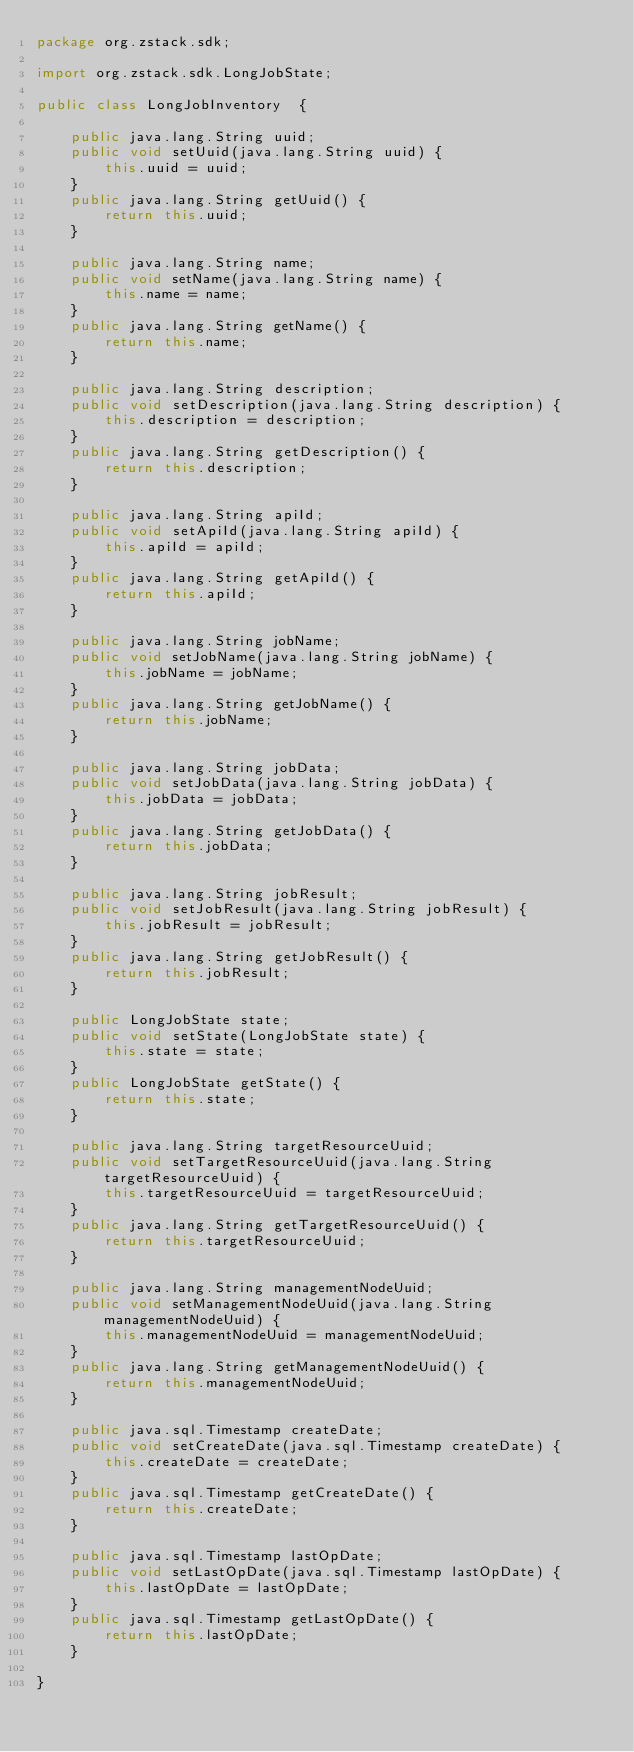<code> <loc_0><loc_0><loc_500><loc_500><_Java_>package org.zstack.sdk;

import org.zstack.sdk.LongJobState;

public class LongJobInventory  {

    public java.lang.String uuid;
    public void setUuid(java.lang.String uuid) {
        this.uuid = uuid;
    }
    public java.lang.String getUuid() {
        return this.uuid;
    }

    public java.lang.String name;
    public void setName(java.lang.String name) {
        this.name = name;
    }
    public java.lang.String getName() {
        return this.name;
    }

    public java.lang.String description;
    public void setDescription(java.lang.String description) {
        this.description = description;
    }
    public java.lang.String getDescription() {
        return this.description;
    }

    public java.lang.String apiId;
    public void setApiId(java.lang.String apiId) {
        this.apiId = apiId;
    }
    public java.lang.String getApiId() {
        return this.apiId;
    }

    public java.lang.String jobName;
    public void setJobName(java.lang.String jobName) {
        this.jobName = jobName;
    }
    public java.lang.String getJobName() {
        return this.jobName;
    }

    public java.lang.String jobData;
    public void setJobData(java.lang.String jobData) {
        this.jobData = jobData;
    }
    public java.lang.String getJobData() {
        return this.jobData;
    }

    public java.lang.String jobResult;
    public void setJobResult(java.lang.String jobResult) {
        this.jobResult = jobResult;
    }
    public java.lang.String getJobResult() {
        return this.jobResult;
    }

    public LongJobState state;
    public void setState(LongJobState state) {
        this.state = state;
    }
    public LongJobState getState() {
        return this.state;
    }

    public java.lang.String targetResourceUuid;
    public void setTargetResourceUuid(java.lang.String targetResourceUuid) {
        this.targetResourceUuid = targetResourceUuid;
    }
    public java.lang.String getTargetResourceUuid() {
        return this.targetResourceUuid;
    }

    public java.lang.String managementNodeUuid;
    public void setManagementNodeUuid(java.lang.String managementNodeUuid) {
        this.managementNodeUuid = managementNodeUuid;
    }
    public java.lang.String getManagementNodeUuid() {
        return this.managementNodeUuid;
    }

    public java.sql.Timestamp createDate;
    public void setCreateDate(java.sql.Timestamp createDate) {
        this.createDate = createDate;
    }
    public java.sql.Timestamp getCreateDate() {
        return this.createDate;
    }

    public java.sql.Timestamp lastOpDate;
    public void setLastOpDate(java.sql.Timestamp lastOpDate) {
        this.lastOpDate = lastOpDate;
    }
    public java.sql.Timestamp getLastOpDate() {
        return this.lastOpDate;
    }

}
</code> 